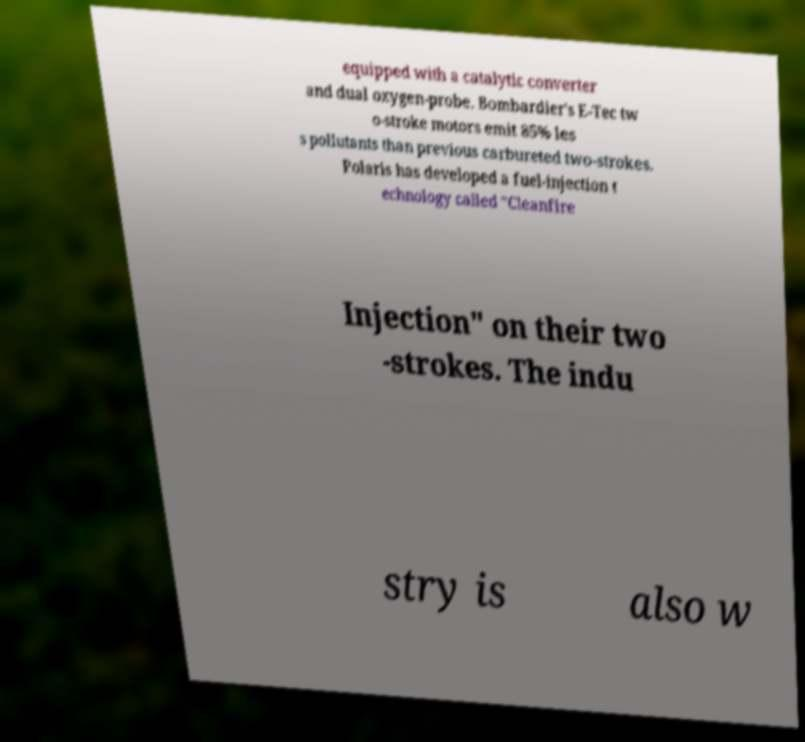I need the written content from this picture converted into text. Can you do that? equipped with a catalytic converter and dual oxygen-probe. Bombardier's E-Tec tw o-stroke motors emit 85% les s pollutants than previous carbureted two-strokes. Polaris has developed a fuel-injection t echnology called "Cleanfire Injection" on their two -strokes. The indu stry is also w 